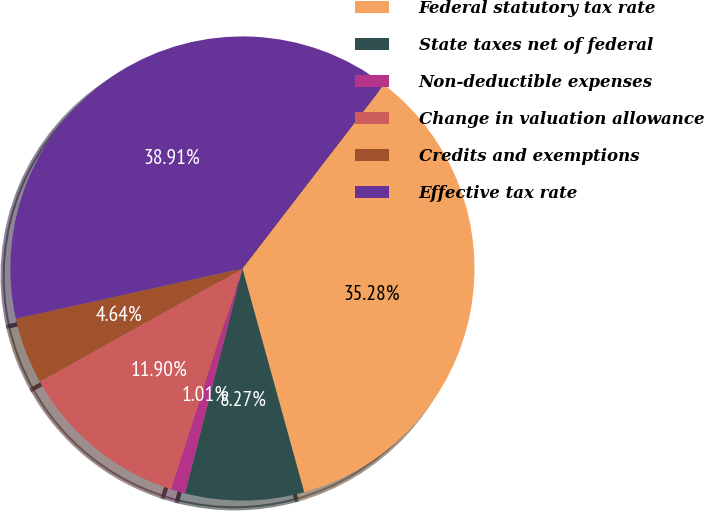Convert chart to OTSL. <chart><loc_0><loc_0><loc_500><loc_500><pie_chart><fcel>Federal statutory tax rate<fcel>State taxes net of federal<fcel>Non-deductible expenses<fcel>Change in valuation allowance<fcel>Credits and exemptions<fcel>Effective tax rate<nl><fcel>35.28%<fcel>8.27%<fcel>1.01%<fcel>11.9%<fcel>4.64%<fcel>38.91%<nl></chart> 